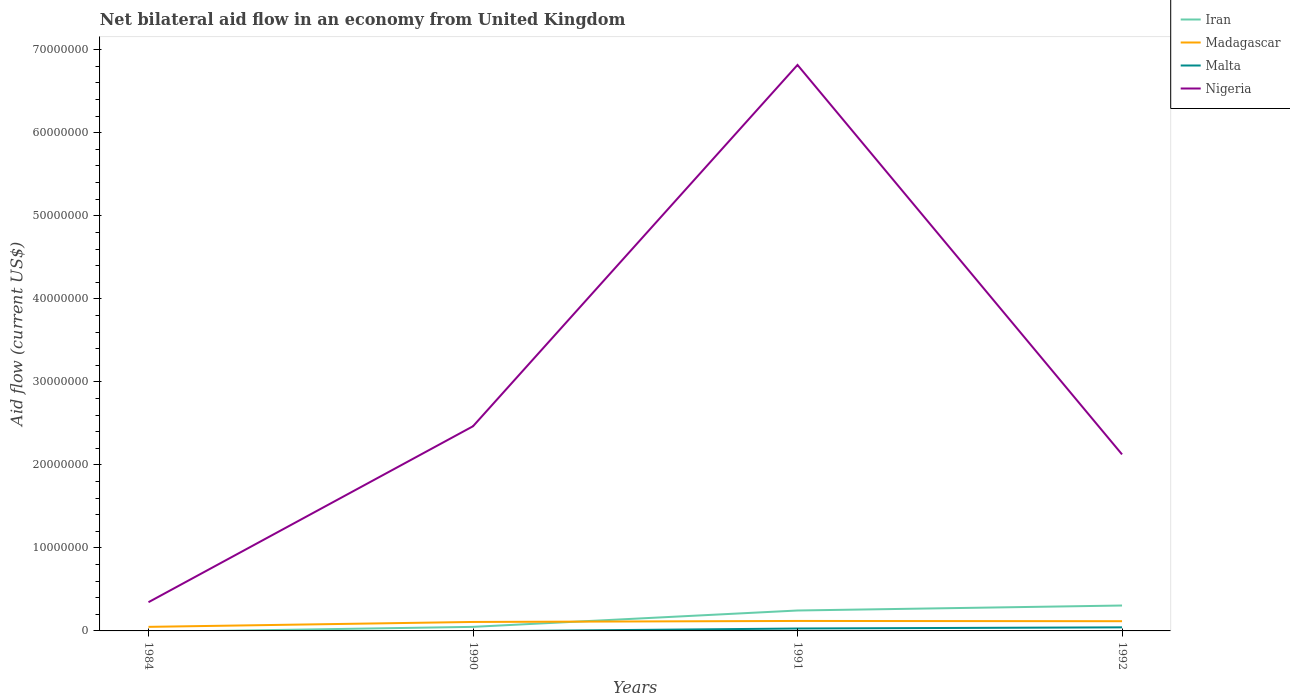How many different coloured lines are there?
Provide a short and direct response. 4. Is the number of lines equal to the number of legend labels?
Provide a succinct answer. No. Across all years, what is the maximum net bilateral aid flow in Madagascar?
Make the answer very short. 4.90e+05. What is the total net bilateral aid flow in Nigeria in the graph?
Keep it short and to the point. -2.12e+07. What is the difference between the highest and the second highest net bilateral aid flow in Iran?
Provide a short and direct response. 3.06e+06. What is the difference between the highest and the lowest net bilateral aid flow in Iran?
Your answer should be compact. 2. Is the net bilateral aid flow in Malta strictly greater than the net bilateral aid flow in Nigeria over the years?
Keep it short and to the point. Yes. How many lines are there?
Your answer should be very brief. 4. Are the values on the major ticks of Y-axis written in scientific E-notation?
Your answer should be compact. No. Where does the legend appear in the graph?
Give a very brief answer. Top right. How many legend labels are there?
Keep it short and to the point. 4. What is the title of the graph?
Offer a terse response. Net bilateral aid flow in an economy from United Kingdom. What is the label or title of the X-axis?
Provide a short and direct response. Years. What is the label or title of the Y-axis?
Keep it short and to the point. Aid flow (current US$). What is the Aid flow (current US$) of Madagascar in 1984?
Provide a succinct answer. 4.90e+05. What is the Aid flow (current US$) in Nigeria in 1984?
Offer a very short reply. 3.46e+06. What is the Aid flow (current US$) of Iran in 1990?
Your answer should be compact. 4.90e+05. What is the Aid flow (current US$) of Madagascar in 1990?
Make the answer very short. 1.08e+06. What is the Aid flow (current US$) of Malta in 1990?
Ensure brevity in your answer.  0. What is the Aid flow (current US$) of Nigeria in 1990?
Provide a short and direct response. 2.46e+07. What is the Aid flow (current US$) of Iran in 1991?
Your answer should be compact. 2.46e+06. What is the Aid flow (current US$) in Madagascar in 1991?
Ensure brevity in your answer.  1.20e+06. What is the Aid flow (current US$) in Malta in 1991?
Your answer should be compact. 2.90e+05. What is the Aid flow (current US$) of Nigeria in 1991?
Your answer should be very brief. 6.82e+07. What is the Aid flow (current US$) of Iran in 1992?
Offer a very short reply. 3.06e+06. What is the Aid flow (current US$) in Madagascar in 1992?
Make the answer very short. 1.17e+06. What is the Aid flow (current US$) in Nigeria in 1992?
Ensure brevity in your answer.  2.13e+07. Across all years, what is the maximum Aid flow (current US$) of Iran?
Your answer should be very brief. 3.06e+06. Across all years, what is the maximum Aid flow (current US$) in Madagascar?
Offer a very short reply. 1.20e+06. Across all years, what is the maximum Aid flow (current US$) in Nigeria?
Keep it short and to the point. 6.82e+07. Across all years, what is the minimum Aid flow (current US$) in Iran?
Keep it short and to the point. 0. Across all years, what is the minimum Aid flow (current US$) in Madagascar?
Keep it short and to the point. 4.90e+05. Across all years, what is the minimum Aid flow (current US$) in Malta?
Ensure brevity in your answer.  0. Across all years, what is the minimum Aid flow (current US$) in Nigeria?
Provide a short and direct response. 3.46e+06. What is the total Aid flow (current US$) of Iran in the graph?
Provide a succinct answer. 6.01e+06. What is the total Aid flow (current US$) of Madagascar in the graph?
Your answer should be compact. 3.94e+06. What is the total Aid flow (current US$) of Malta in the graph?
Ensure brevity in your answer.  7.20e+05. What is the total Aid flow (current US$) in Nigeria in the graph?
Your answer should be compact. 1.18e+08. What is the difference between the Aid flow (current US$) in Madagascar in 1984 and that in 1990?
Offer a very short reply. -5.90e+05. What is the difference between the Aid flow (current US$) in Nigeria in 1984 and that in 1990?
Your answer should be compact. -2.12e+07. What is the difference between the Aid flow (current US$) in Madagascar in 1984 and that in 1991?
Your answer should be compact. -7.10e+05. What is the difference between the Aid flow (current US$) in Nigeria in 1984 and that in 1991?
Ensure brevity in your answer.  -6.47e+07. What is the difference between the Aid flow (current US$) of Madagascar in 1984 and that in 1992?
Offer a terse response. -6.80e+05. What is the difference between the Aid flow (current US$) of Nigeria in 1984 and that in 1992?
Your response must be concise. -1.78e+07. What is the difference between the Aid flow (current US$) of Iran in 1990 and that in 1991?
Keep it short and to the point. -1.97e+06. What is the difference between the Aid flow (current US$) of Madagascar in 1990 and that in 1991?
Ensure brevity in your answer.  -1.20e+05. What is the difference between the Aid flow (current US$) of Nigeria in 1990 and that in 1991?
Give a very brief answer. -4.35e+07. What is the difference between the Aid flow (current US$) in Iran in 1990 and that in 1992?
Provide a succinct answer. -2.57e+06. What is the difference between the Aid flow (current US$) of Nigeria in 1990 and that in 1992?
Your response must be concise. 3.39e+06. What is the difference between the Aid flow (current US$) in Iran in 1991 and that in 1992?
Offer a terse response. -6.00e+05. What is the difference between the Aid flow (current US$) of Madagascar in 1991 and that in 1992?
Give a very brief answer. 3.00e+04. What is the difference between the Aid flow (current US$) in Malta in 1991 and that in 1992?
Your answer should be very brief. -1.40e+05. What is the difference between the Aid flow (current US$) in Nigeria in 1991 and that in 1992?
Provide a succinct answer. 4.69e+07. What is the difference between the Aid flow (current US$) of Madagascar in 1984 and the Aid flow (current US$) of Nigeria in 1990?
Your answer should be very brief. -2.42e+07. What is the difference between the Aid flow (current US$) in Madagascar in 1984 and the Aid flow (current US$) in Nigeria in 1991?
Provide a short and direct response. -6.77e+07. What is the difference between the Aid flow (current US$) in Madagascar in 1984 and the Aid flow (current US$) in Malta in 1992?
Keep it short and to the point. 6.00e+04. What is the difference between the Aid flow (current US$) of Madagascar in 1984 and the Aid flow (current US$) of Nigeria in 1992?
Provide a succinct answer. -2.08e+07. What is the difference between the Aid flow (current US$) of Iran in 1990 and the Aid flow (current US$) of Madagascar in 1991?
Make the answer very short. -7.10e+05. What is the difference between the Aid flow (current US$) of Iran in 1990 and the Aid flow (current US$) of Nigeria in 1991?
Make the answer very short. -6.77e+07. What is the difference between the Aid flow (current US$) in Madagascar in 1990 and the Aid flow (current US$) in Malta in 1991?
Make the answer very short. 7.90e+05. What is the difference between the Aid flow (current US$) in Madagascar in 1990 and the Aid flow (current US$) in Nigeria in 1991?
Provide a short and direct response. -6.71e+07. What is the difference between the Aid flow (current US$) of Iran in 1990 and the Aid flow (current US$) of Madagascar in 1992?
Keep it short and to the point. -6.80e+05. What is the difference between the Aid flow (current US$) of Iran in 1990 and the Aid flow (current US$) of Nigeria in 1992?
Provide a short and direct response. -2.08e+07. What is the difference between the Aid flow (current US$) in Madagascar in 1990 and the Aid flow (current US$) in Malta in 1992?
Your answer should be compact. 6.50e+05. What is the difference between the Aid flow (current US$) of Madagascar in 1990 and the Aid flow (current US$) of Nigeria in 1992?
Provide a succinct answer. -2.02e+07. What is the difference between the Aid flow (current US$) of Iran in 1991 and the Aid flow (current US$) of Madagascar in 1992?
Make the answer very short. 1.29e+06. What is the difference between the Aid flow (current US$) in Iran in 1991 and the Aid flow (current US$) in Malta in 1992?
Give a very brief answer. 2.03e+06. What is the difference between the Aid flow (current US$) in Iran in 1991 and the Aid flow (current US$) in Nigeria in 1992?
Ensure brevity in your answer.  -1.88e+07. What is the difference between the Aid flow (current US$) of Madagascar in 1991 and the Aid flow (current US$) of Malta in 1992?
Ensure brevity in your answer.  7.70e+05. What is the difference between the Aid flow (current US$) of Madagascar in 1991 and the Aid flow (current US$) of Nigeria in 1992?
Provide a short and direct response. -2.01e+07. What is the difference between the Aid flow (current US$) in Malta in 1991 and the Aid flow (current US$) in Nigeria in 1992?
Provide a short and direct response. -2.10e+07. What is the average Aid flow (current US$) in Iran per year?
Your answer should be compact. 1.50e+06. What is the average Aid flow (current US$) of Madagascar per year?
Your answer should be compact. 9.85e+05. What is the average Aid flow (current US$) in Malta per year?
Give a very brief answer. 1.80e+05. What is the average Aid flow (current US$) of Nigeria per year?
Your answer should be very brief. 2.94e+07. In the year 1984, what is the difference between the Aid flow (current US$) in Madagascar and Aid flow (current US$) in Nigeria?
Your answer should be very brief. -2.97e+06. In the year 1990, what is the difference between the Aid flow (current US$) of Iran and Aid flow (current US$) of Madagascar?
Your answer should be very brief. -5.90e+05. In the year 1990, what is the difference between the Aid flow (current US$) in Iran and Aid flow (current US$) in Nigeria?
Offer a very short reply. -2.42e+07. In the year 1990, what is the difference between the Aid flow (current US$) of Madagascar and Aid flow (current US$) of Nigeria?
Make the answer very short. -2.36e+07. In the year 1991, what is the difference between the Aid flow (current US$) in Iran and Aid flow (current US$) in Madagascar?
Ensure brevity in your answer.  1.26e+06. In the year 1991, what is the difference between the Aid flow (current US$) of Iran and Aid flow (current US$) of Malta?
Keep it short and to the point. 2.17e+06. In the year 1991, what is the difference between the Aid flow (current US$) of Iran and Aid flow (current US$) of Nigeria?
Your response must be concise. -6.57e+07. In the year 1991, what is the difference between the Aid flow (current US$) in Madagascar and Aid flow (current US$) in Malta?
Offer a terse response. 9.10e+05. In the year 1991, what is the difference between the Aid flow (current US$) in Madagascar and Aid flow (current US$) in Nigeria?
Offer a terse response. -6.70e+07. In the year 1991, what is the difference between the Aid flow (current US$) in Malta and Aid flow (current US$) in Nigeria?
Make the answer very short. -6.79e+07. In the year 1992, what is the difference between the Aid flow (current US$) of Iran and Aid flow (current US$) of Madagascar?
Make the answer very short. 1.89e+06. In the year 1992, what is the difference between the Aid flow (current US$) in Iran and Aid flow (current US$) in Malta?
Provide a succinct answer. 2.63e+06. In the year 1992, what is the difference between the Aid flow (current US$) in Iran and Aid flow (current US$) in Nigeria?
Make the answer very short. -1.82e+07. In the year 1992, what is the difference between the Aid flow (current US$) of Madagascar and Aid flow (current US$) of Malta?
Offer a very short reply. 7.40e+05. In the year 1992, what is the difference between the Aid flow (current US$) of Madagascar and Aid flow (current US$) of Nigeria?
Ensure brevity in your answer.  -2.01e+07. In the year 1992, what is the difference between the Aid flow (current US$) of Malta and Aid flow (current US$) of Nigeria?
Your answer should be compact. -2.08e+07. What is the ratio of the Aid flow (current US$) of Madagascar in 1984 to that in 1990?
Keep it short and to the point. 0.45. What is the ratio of the Aid flow (current US$) in Nigeria in 1984 to that in 1990?
Ensure brevity in your answer.  0.14. What is the ratio of the Aid flow (current US$) in Madagascar in 1984 to that in 1991?
Provide a succinct answer. 0.41. What is the ratio of the Aid flow (current US$) in Nigeria in 1984 to that in 1991?
Your response must be concise. 0.05. What is the ratio of the Aid flow (current US$) of Madagascar in 1984 to that in 1992?
Provide a succinct answer. 0.42. What is the ratio of the Aid flow (current US$) in Nigeria in 1984 to that in 1992?
Your answer should be compact. 0.16. What is the ratio of the Aid flow (current US$) in Iran in 1990 to that in 1991?
Your answer should be very brief. 0.2. What is the ratio of the Aid flow (current US$) of Madagascar in 1990 to that in 1991?
Your answer should be very brief. 0.9. What is the ratio of the Aid flow (current US$) in Nigeria in 1990 to that in 1991?
Offer a terse response. 0.36. What is the ratio of the Aid flow (current US$) of Iran in 1990 to that in 1992?
Your answer should be compact. 0.16. What is the ratio of the Aid flow (current US$) of Nigeria in 1990 to that in 1992?
Your response must be concise. 1.16. What is the ratio of the Aid flow (current US$) in Iran in 1991 to that in 1992?
Offer a very short reply. 0.8. What is the ratio of the Aid flow (current US$) in Madagascar in 1991 to that in 1992?
Ensure brevity in your answer.  1.03. What is the ratio of the Aid flow (current US$) in Malta in 1991 to that in 1992?
Ensure brevity in your answer.  0.67. What is the ratio of the Aid flow (current US$) of Nigeria in 1991 to that in 1992?
Provide a short and direct response. 3.21. What is the difference between the highest and the second highest Aid flow (current US$) in Iran?
Offer a very short reply. 6.00e+05. What is the difference between the highest and the second highest Aid flow (current US$) of Madagascar?
Your response must be concise. 3.00e+04. What is the difference between the highest and the second highest Aid flow (current US$) of Nigeria?
Your response must be concise. 4.35e+07. What is the difference between the highest and the lowest Aid flow (current US$) of Iran?
Make the answer very short. 3.06e+06. What is the difference between the highest and the lowest Aid flow (current US$) of Madagascar?
Keep it short and to the point. 7.10e+05. What is the difference between the highest and the lowest Aid flow (current US$) in Nigeria?
Your response must be concise. 6.47e+07. 